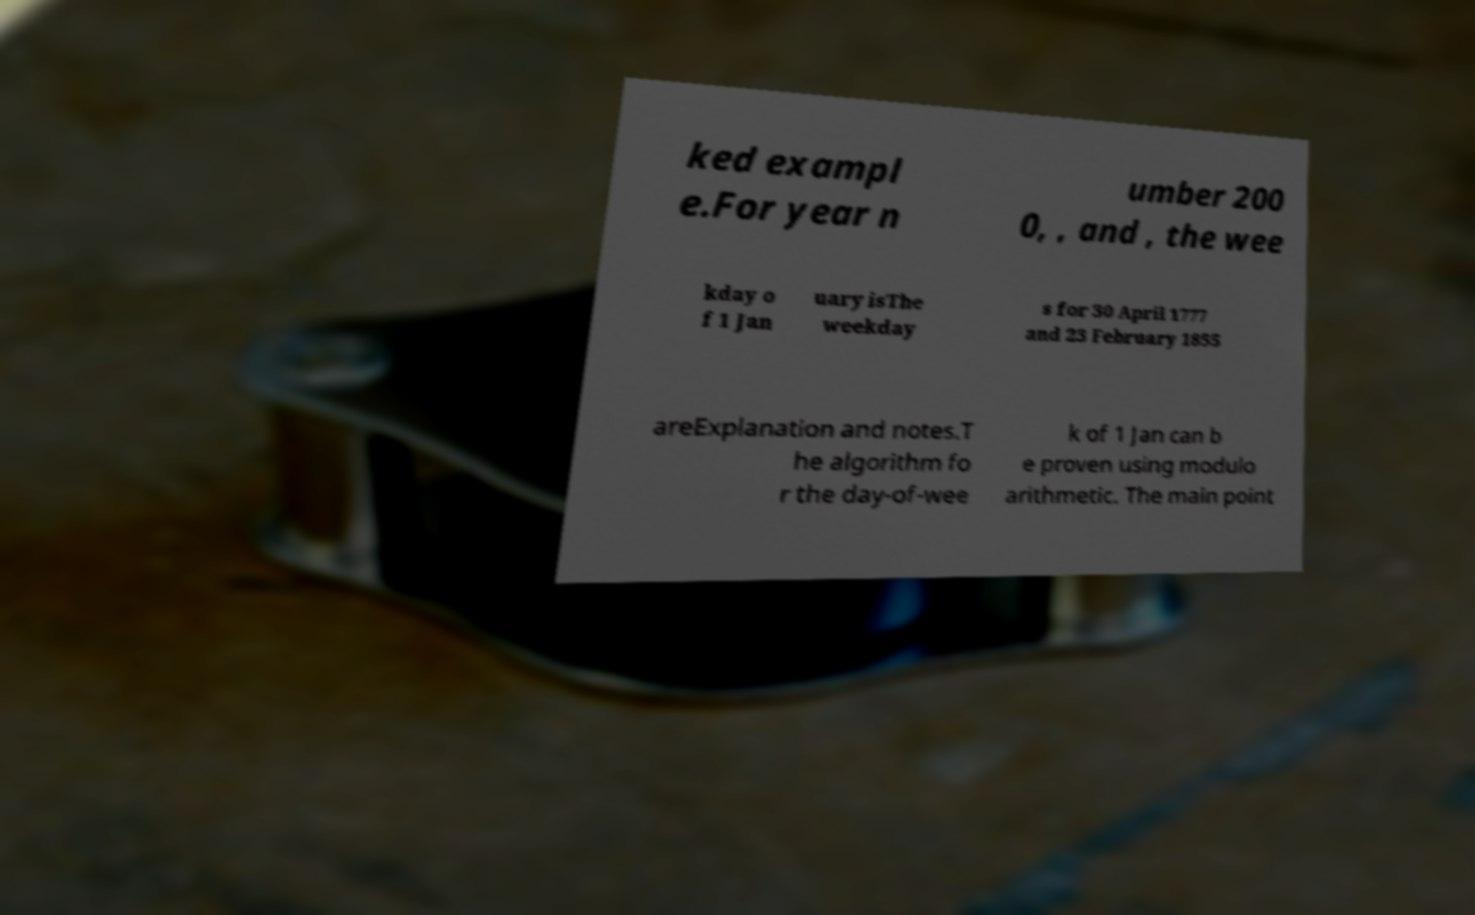Could you extract and type out the text from this image? ked exampl e.For year n umber 200 0, , and , the wee kday o f 1 Jan uary isThe weekday s for 30 April 1777 and 23 February 1855 areExplanation and notes.T he algorithm fo r the day-of-wee k of 1 Jan can b e proven using modulo arithmetic. The main point 